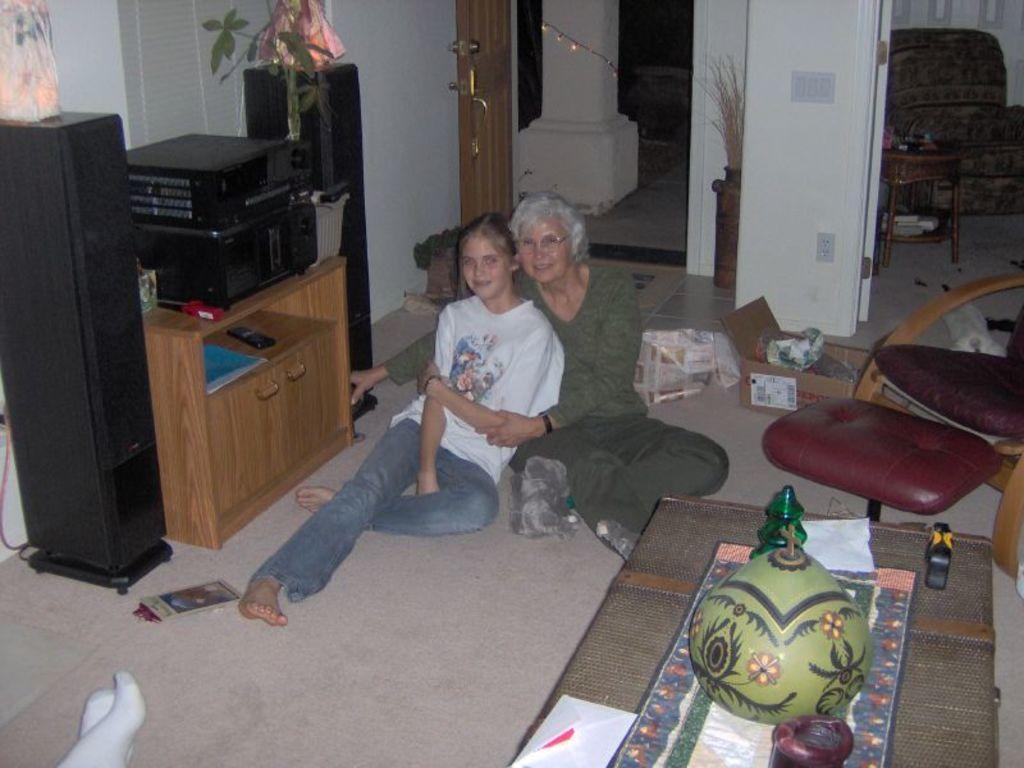Could you give a brief overview of what you see in this image? This picture is inside the room. There are two persons sitting on the floor. At the right side of the image there is a chair and cardboard box, at the back side of the image there is a door, at the left there are speakers, desk and plant and in the front there is a bottle, paper on the table. 